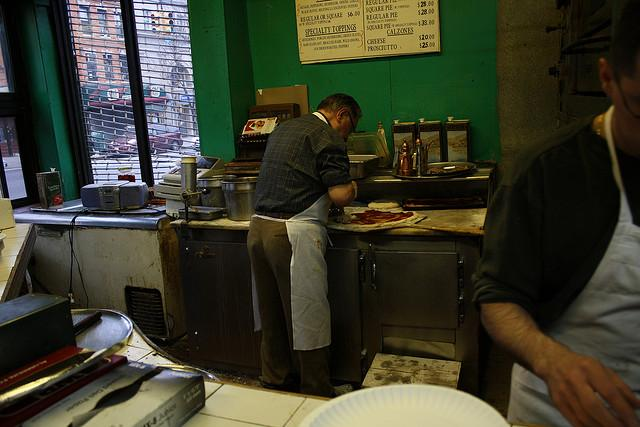Who regularly wore the item the man has over his pants?

Choices:
A) man ray
B) ray charles
C) ray lewis
D) rachel ray rachel ray 